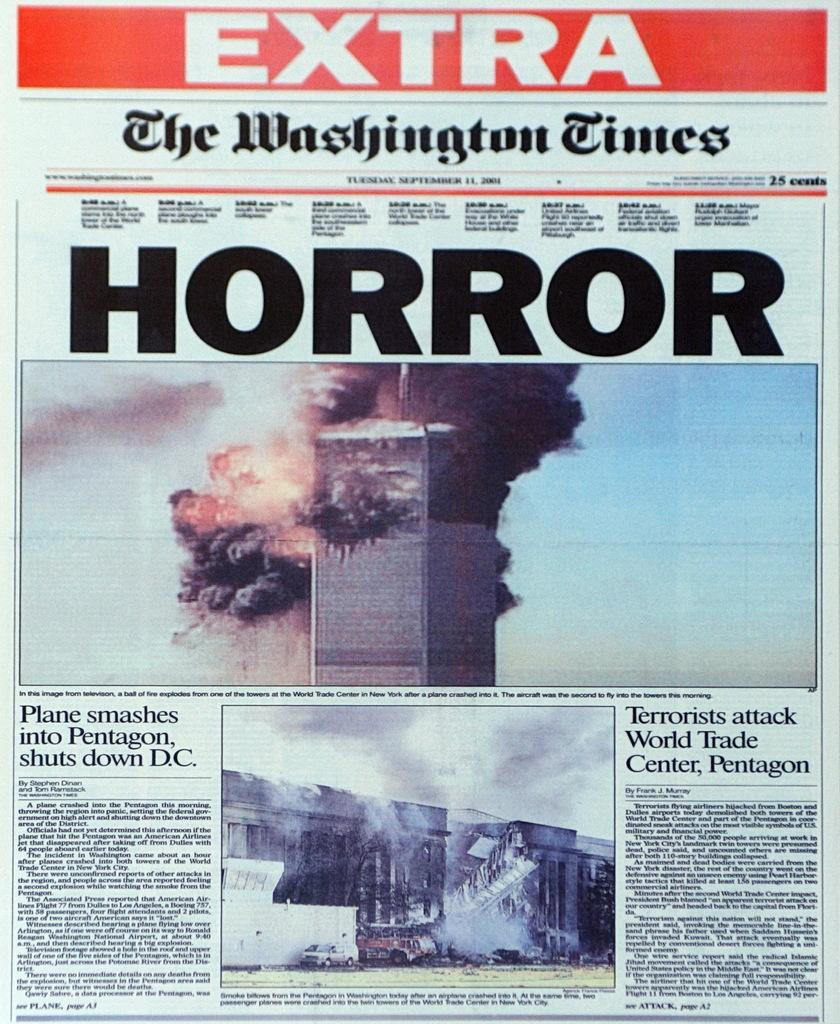What is the main subject of the picture? The main subject of the picture is a news article. What types of photos are included in the news article? The news article contains photos of buildings, fire, and smoke. What can be seen in the background of the photos? The sky is visible in the photos. Are there any other elements visible in the photos? Yes, there are other things visible in the photos. Is there any text on the news article? Yes, there is text written on the news article. Are there any bushes visible in the photos? There is no mention of bushes in the provided facts, so we cannot determine if they are visible in the photos. Is there any quicksand visible in the photos? There is no mention of quicksand in the provided facts, so we cannot determine if it is visible in the photos. 